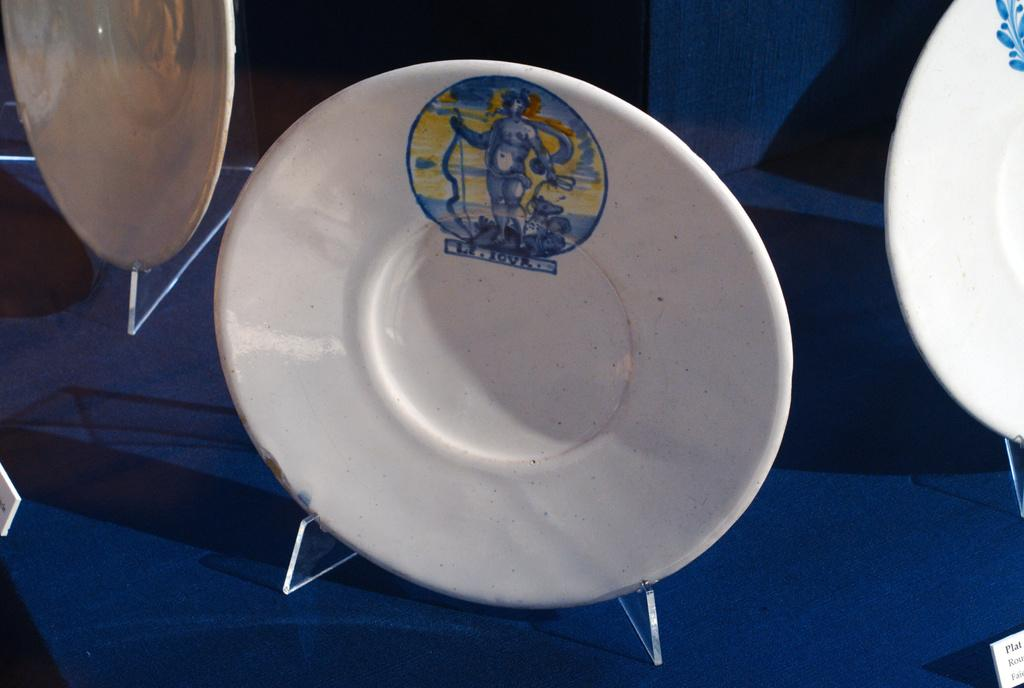What objects are present on the table in the image? There are saucers with prints on the table. What color is the table in the image? The table is blue. What can be seen in the background of the image? There is a wall visible in the background of the image. What type of canvas is being used to crush the eggnog in the image? There is no canvas or eggnog present in the image; it features saucers with prints on a blue table with a wall visible in the background. 